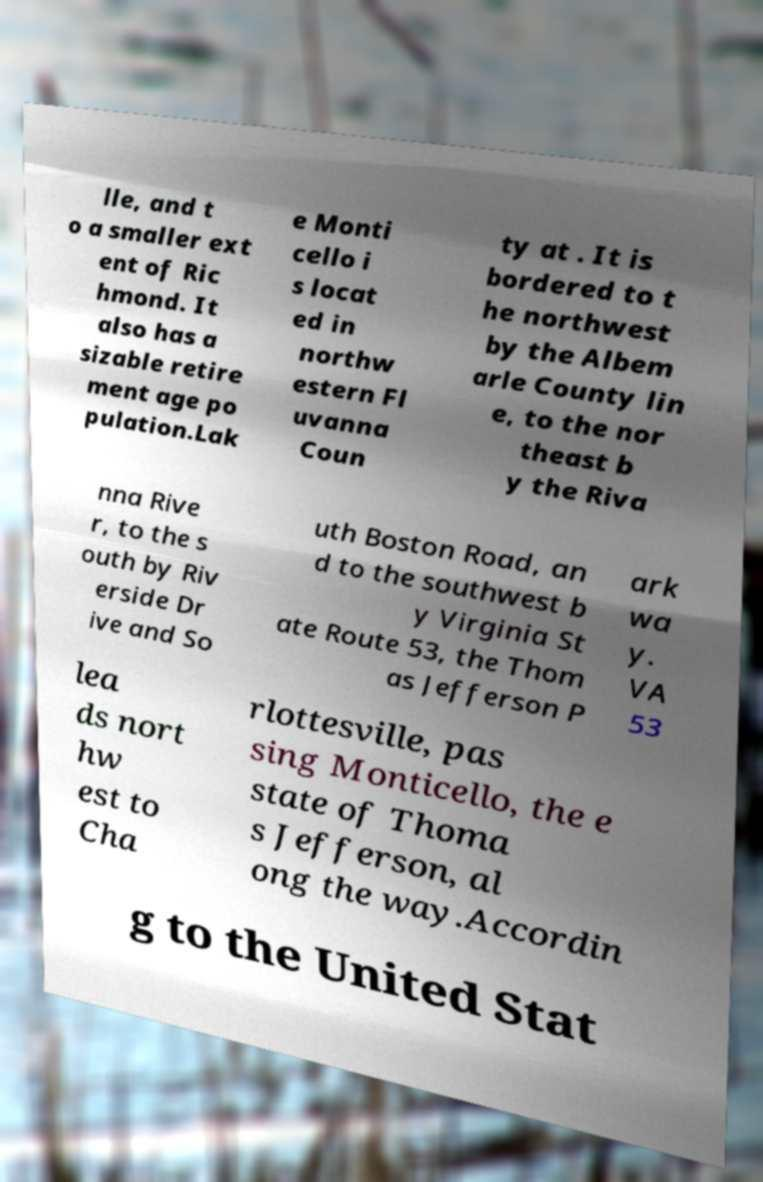For documentation purposes, I need the text within this image transcribed. Could you provide that? lle, and t o a smaller ext ent of Ric hmond. It also has a sizable retire ment age po pulation.Lak e Monti cello i s locat ed in northw estern Fl uvanna Coun ty at . It is bordered to t he northwest by the Albem arle County lin e, to the nor theast b y the Riva nna Rive r, to the s outh by Riv erside Dr ive and So uth Boston Road, an d to the southwest b y Virginia St ate Route 53, the Thom as Jefferson P ark wa y. VA 53 lea ds nort hw est to Cha rlottesville, pas sing Monticello, the e state of Thoma s Jefferson, al ong the way.Accordin g to the United Stat 